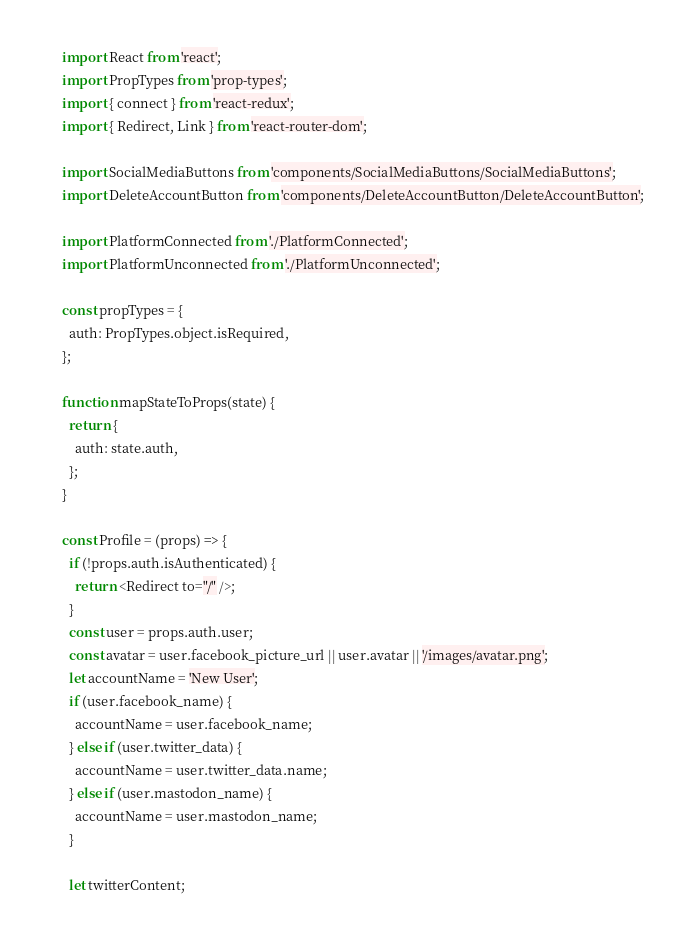<code> <loc_0><loc_0><loc_500><loc_500><_JavaScript_>import React from 'react';
import PropTypes from 'prop-types';
import { connect } from 'react-redux';
import { Redirect, Link } from 'react-router-dom';

import SocialMediaButtons from 'components/SocialMediaButtons/SocialMediaButtons';
import DeleteAccountButton from 'components/DeleteAccountButton/DeleteAccountButton';

import PlatformConnected from './PlatformConnected';
import PlatformUnconnected from './PlatformUnconnected';

const propTypes = {
  auth: PropTypes.object.isRequired,
};

function mapStateToProps(state) {
  return {
    auth: state.auth,
  };
}

const Profile = (props) => {
  if (!props.auth.isAuthenticated) {
    return <Redirect to="/" />;
  }
  const user = props.auth.user;
  const avatar = user.facebook_picture_url || user.avatar || '/images/avatar.png';
  let accountName = 'New User';
  if (user.facebook_name) {
    accountName = user.facebook_name;
  } else if (user.twitter_data) {
    accountName = user.twitter_data.name;
  } else if (user.mastodon_name) {
    accountName = user.mastodon_name;
  }

  let twitterContent;</code> 